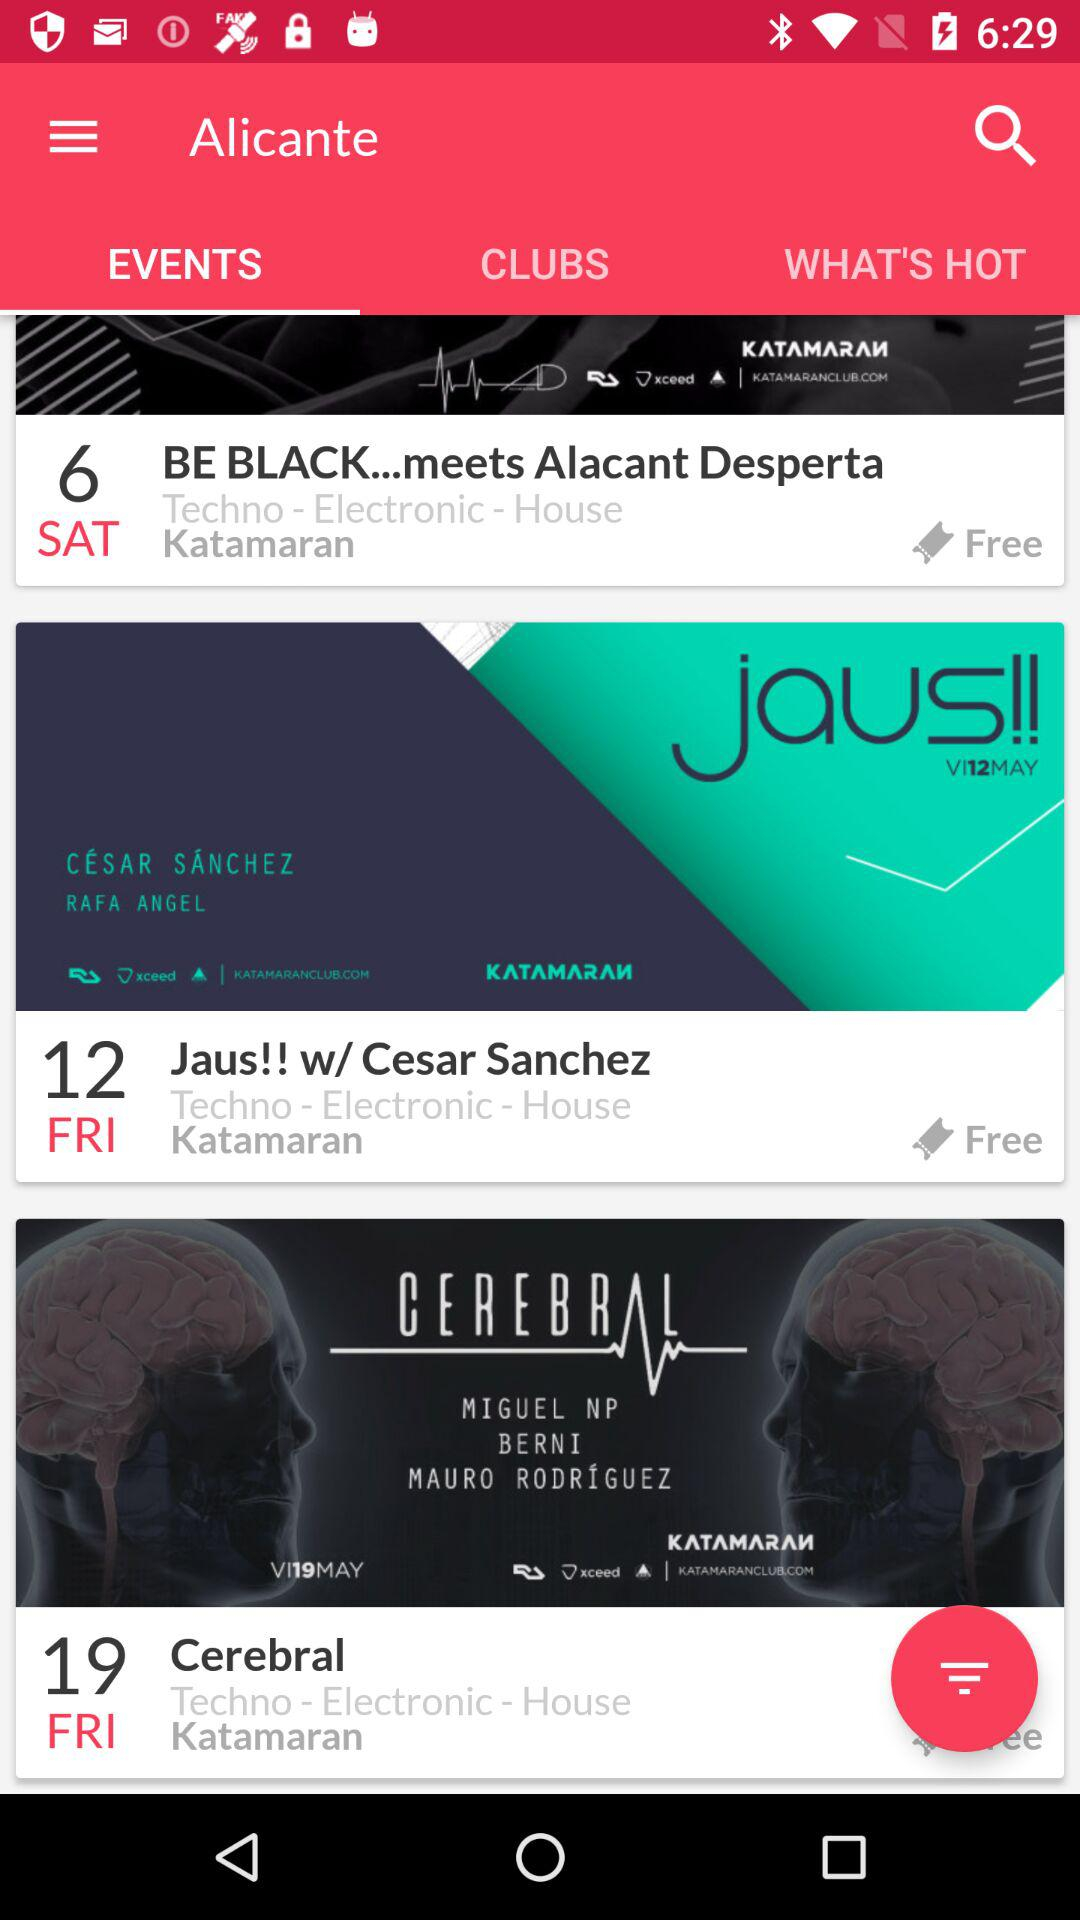How many events are displayed on the screen?
Answer the question using a single word or phrase. 3 